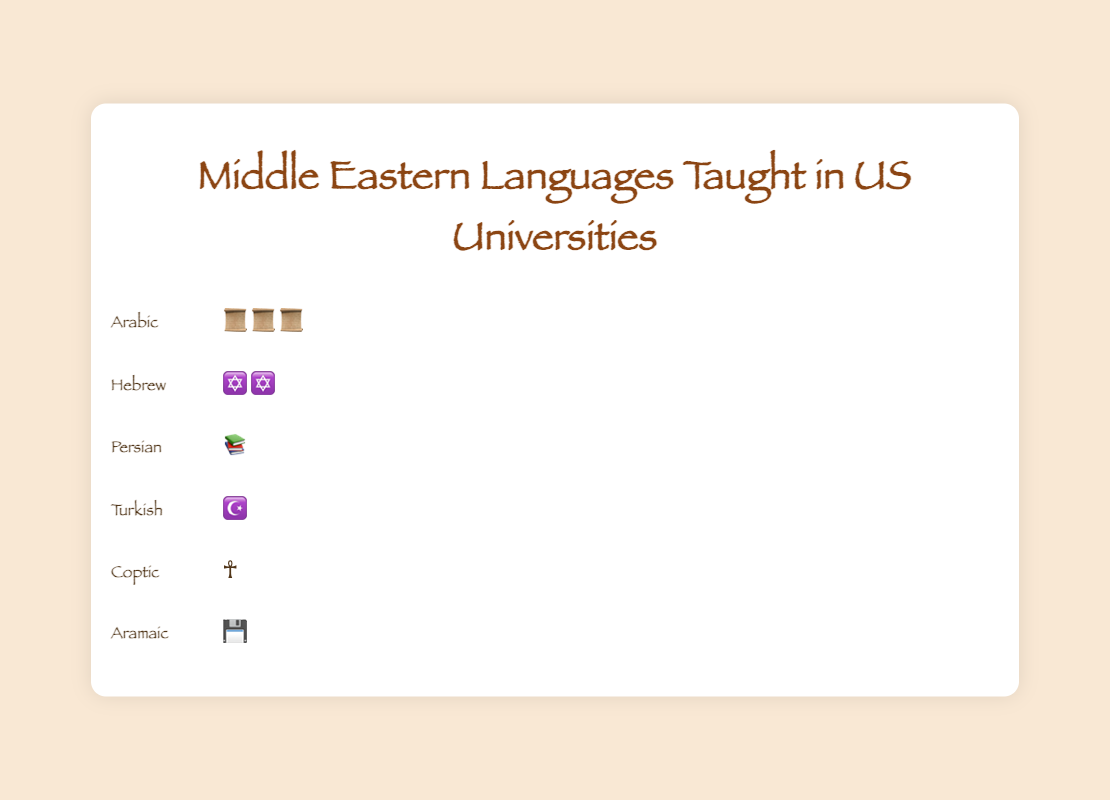What is the title of the figure? The title of the figure is displayed at the top of the chart and typically describes the content or focus of the visual representation.
Answer: "Middle Eastern Languages Taught in US Universities" How many universities teach the Arabic language? By observing the icons representing Arabic in the figure and counting them, we can determine the number of universities that offer Arabic.
Answer: 230 How many different languages are represented in the figure? By counting the distinct language names on the chart for each row, we can establish the number of different languages visualized.
Answer: 6 Which language is taught in the fewest number of universities? The language with the least number of icons shown in its row indicates the fewest representations in universities.
Answer: Aramaic How many more universities teach Arabic than Hebrew? First, identify the number of universities that teach Arabic and Hebrew, and then subtract the smaller number from the larger one. Arabic is taught in 230 universities and Hebrew in 120. So, 230 - 120 equals 110.
Answer: 110 Is Coptic taught in more universities than Persian? Compare the number of universities for Coptic and Persian by observing the count of their respective icons. Coptic is taught in 15 universities, while Persian is taught in 65.
Answer: No What is the total number of universities teaching Turkish and Aramaic combined? Add the number of universities for Turkish and Aramaic by counting their respective icons. Turkish is taught in 40 universities, and Aramaic in 10 universities, so 40 + 10 equals 50.
Answer: 50 Which language has the second-highest number of universities teaching it? By comparing the number of icons visually, determine which language has the second most after Arabic. Hebrew has the next highest with 120 universities.
Answer: Hebrew Approximately what fraction of the universities teaching Arabic also teach Coptic? Calculate the fraction by dividing the number of universities teaching Coptic by the number teaching Arabic and then simplifying the fraction. 15 (Coptic) divided by 230 (Arabic) is approximately 1/15.3, which simplifies to about 1/15.
Answer: 1/15 